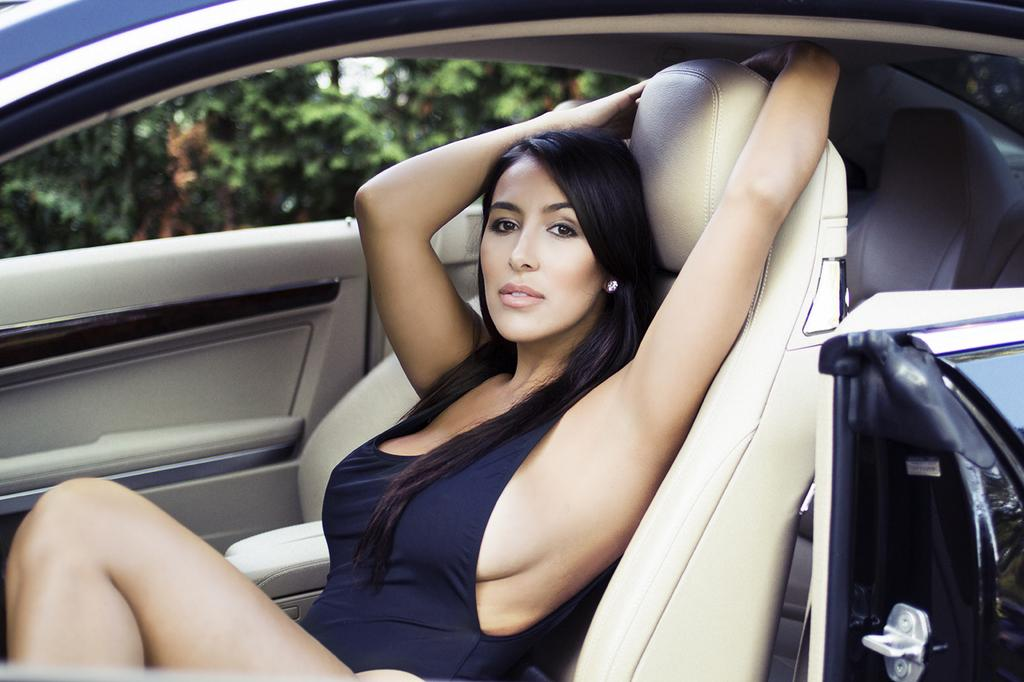Who is present in the image? There is a woman in the image. What is the woman doing in the image? The woman is sitting in a car. What can be seen in the background of the image? There are trees visible in the image. How many sheep are visible in the image? There are no sheep present in the image. What type of cheese is the woman holding in the image? The woman is not holding any cheese in the image. 